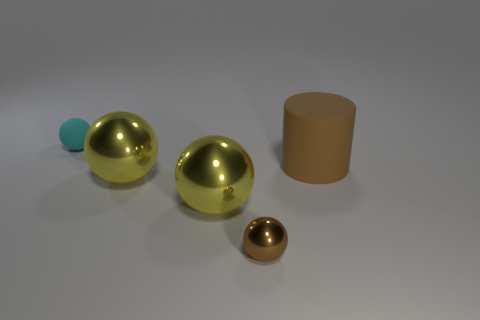Add 2 large balls. How many objects exist? 7 Subtract all blue spheres. Subtract all blue cubes. How many spheres are left? 4 Subtract all cylinders. How many objects are left? 4 Add 5 large metal objects. How many large metal objects are left? 7 Add 4 rubber things. How many rubber things exist? 6 Subtract 0 blue blocks. How many objects are left? 5 Subtract all small cyan objects. Subtract all rubber objects. How many objects are left? 2 